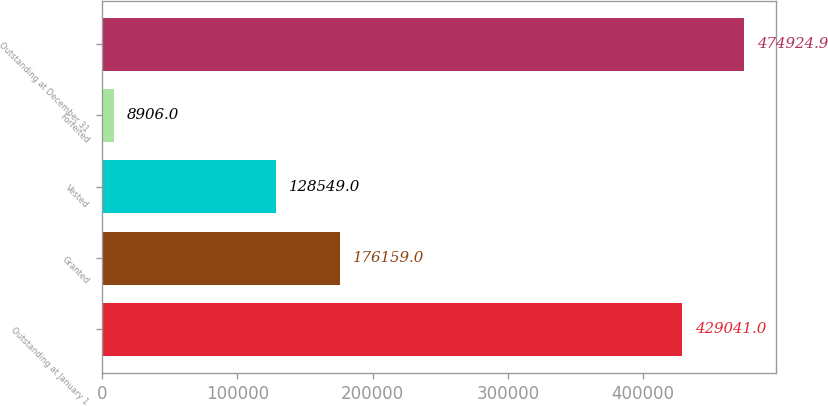Convert chart to OTSL. <chart><loc_0><loc_0><loc_500><loc_500><bar_chart><fcel>Outstanding at January 1<fcel>Granted<fcel>Vested<fcel>Forfeited<fcel>Outstanding at December 31<nl><fcel>429041<fcel>176159<fcel>128549<fcel>8906<fcel>474925<nl></chart> 